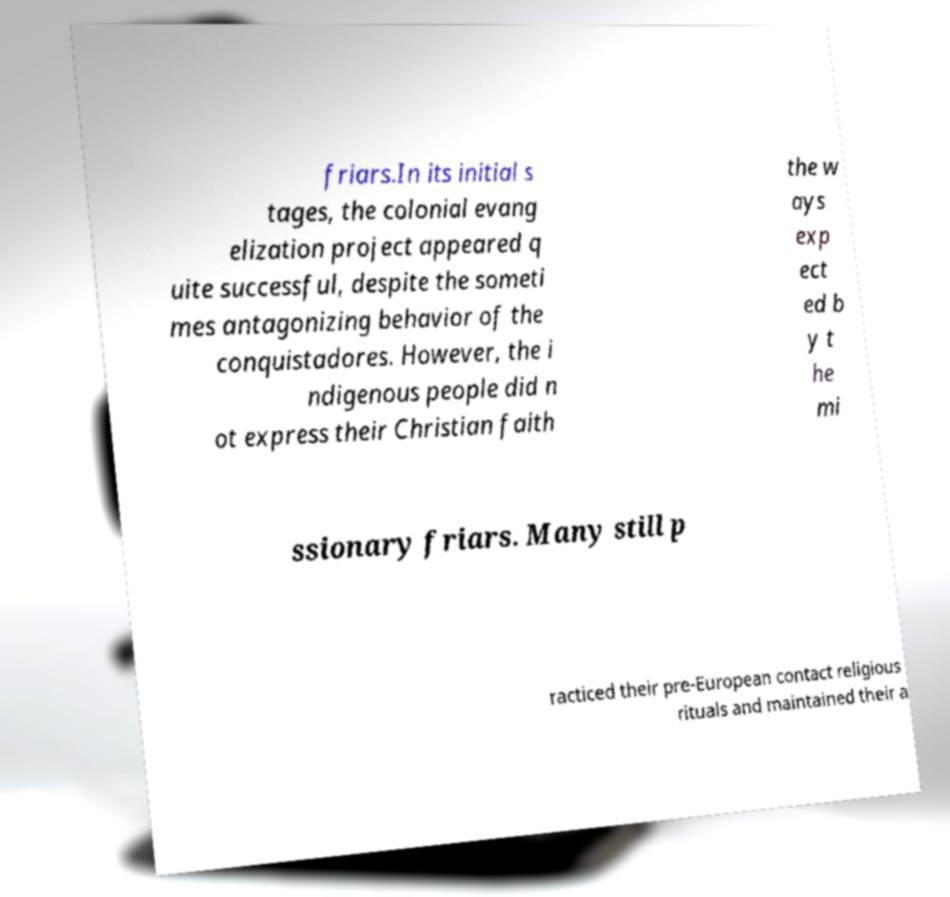Please identify and transcribe the text found in this image. friars.In its initial s tages, the colonial evang elization project appeared q uite successful, despite the someti mes antagonizing behavior of the conquistadores. However, the i ndigenous people did n ot express their Christian faith the w ays exp ect ed b y t he mi ssionary friars. Many still p racticed their pre-European contact religious rituals and maintained their a 